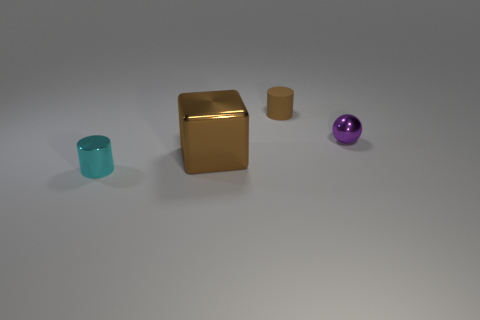Add 2 small brown things. How many objects exist? 6 Subtract all balls. How many objects are left? 3 Add 2 small cyan metallic objects. How many small cyan metallic objects are left? 3 Add 2 tiny cyan metal objects. How many tiny cyan metal objects exist? 3 Subtract 1 brown cubes. How many objects are left? 3 Subtract all big cubes. Subtract all tiny cyan things. How many objects are left? 2 